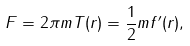<formula> <loc_0><loc_0><loc_500><loc_500>F = 2 \pi m T ( r ) = \frac { 1 } { 2 } m f ^ { \prime } ( r ) ,</formula> 